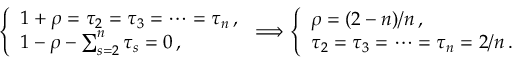Convert formula to latex. <formula><loc_0><loc_0><loc_500><loc_500>\left \{ \begin{array} { l } { { 1 + \rho = \tau _ { 2 } = \tau _ { 3 } = \cdots = \tau _ { n } \, , } } \\ { { 1 - \rho - \sum _ { s = 2 } ^ { n } \tau _ { s } = 0 \, , } } \end{array} \Longrightarrow \left \{ \begin{array} { l } { \rho = ( 2 - n ) / n \, , } \\ { { \tau _ { 2 } = \tau _ { 3 } = \cdots = \tau _ { n } = 2 / n \, . } } \end{array}</formula> 